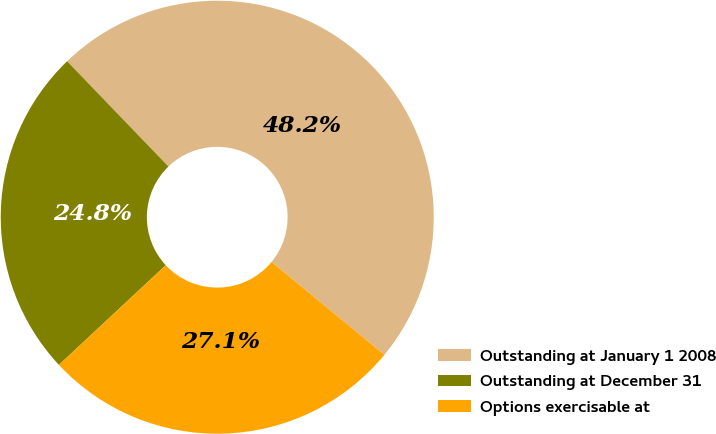<chart> <loc_0><loc_0><loc_500><loc_500><pie_chart><fcel>Outstanding at January 1 2008<fcel>Outstanding at December 31<fcel>Options exercisable at<nl><fcel>48.16%<fcel>24.75%<fcel>27.09%<nl></chart> 